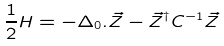Convert formula to latex. <formula><loc_0><loc_0><loc_500><loc_500>\frac { 1 } { 2 } H = - \Delta _ { 0 } . \vec { Z } - \vec { Z } ^ { \dagger } C ^ { - 1 } \vec { Z }</formula> 